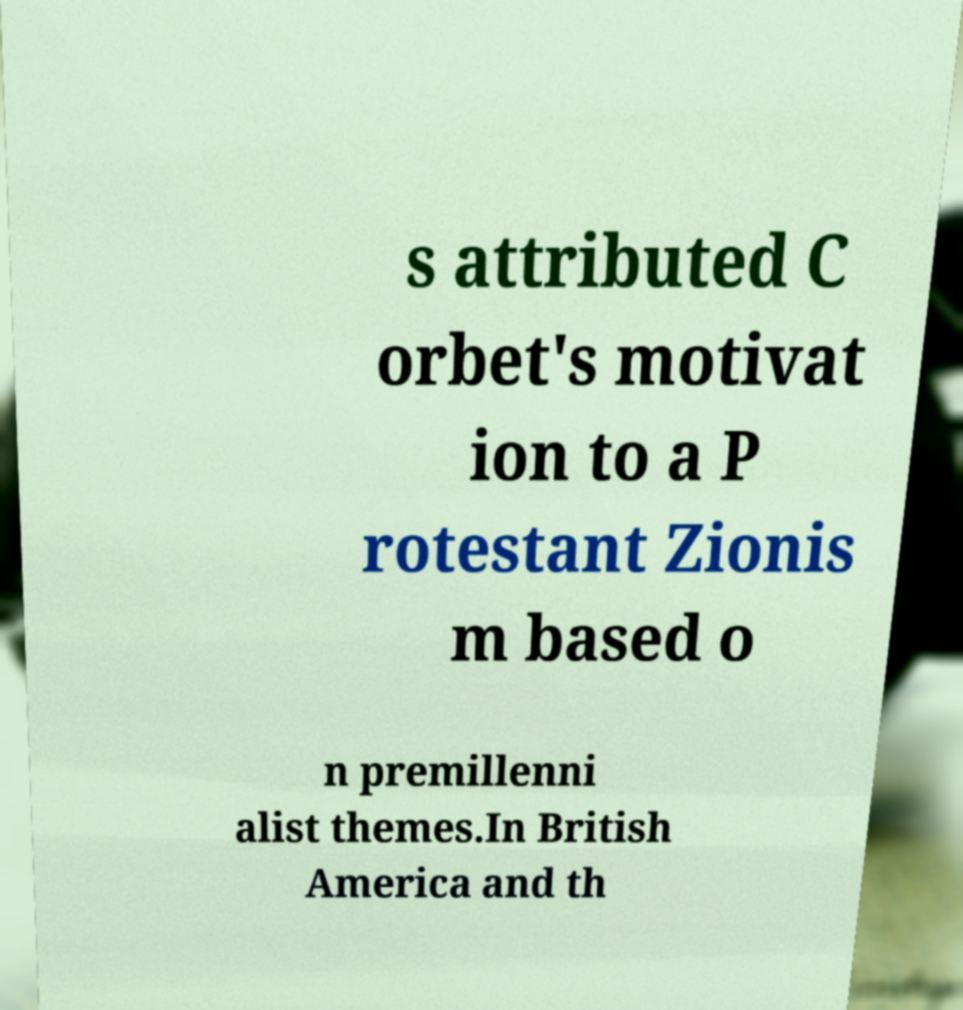Could you assist in decoding the text presented in this image and type it out clearly? s attributed C orbet's motivat ion to a P rotestant Zionis m based o n premillenni alist themes.In British America and th 